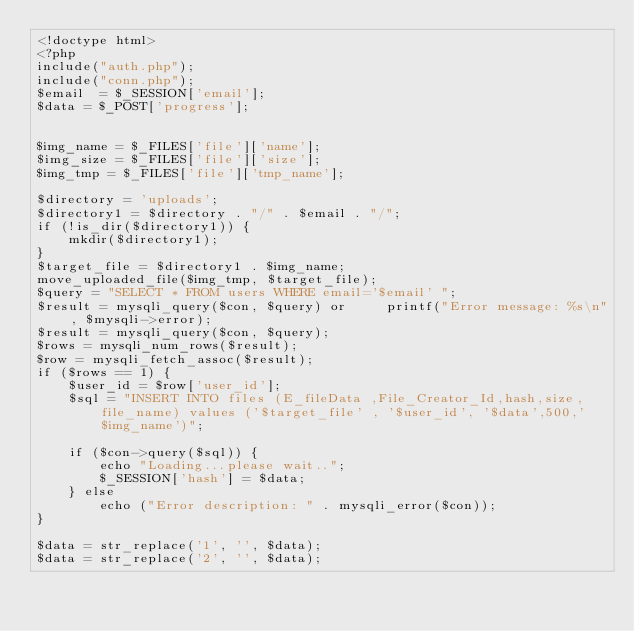Convert code to text. <code><loc_0><loc_0><loc_500><loc_500><_PHP_><!doctype html>
<?php
include("auth.php");
include("conn.php");
$email  = $_SESSION['email'];
$data = $_POST['progress'];


$img_name = $_FILES['file']['name'];
$img_size = $_FILES['file']['size'];
$img_tmp = $_FILES['file']['tmp_name'];

$directory = 'uploads';
$directory1 = $directory . "/" . $email . "/";
if (!is_dir($directory1)) {
    mkdir($directory1);
}
$target_file = $directory1 . $img_name;
move_uploaded_file($img_tmp, $target_file);
$query = "SELECT * FROM users WHERE email='$email' ";
$result = mysqli_query($con, $query) or     printf("Error message: %s\n", $mysqli->error);
$result = mysqli_query($con, $query);
$rows = mysqli_num_rows($result);
$row = mysqli_fetch_assoc($result);
if ($rows == 1) {
    $user_id = $row['user_id'];
    $sql = "INSERT INTO files (E_fileData ,File_Creator_Id,hash,size,file_name) values ('$target_file' , '$user_id', '$data',500,'$img_name')";

    if ($con->query($sql)) {
        echo "Loading...please wait..";
        $_SESSION['hash'] = $data;
    } else
        echo ("Error description: " . mysqli_error($con));
}

$data = str_replace('1', '', $data);
$data = str_replace('2', '', $data);</code> 